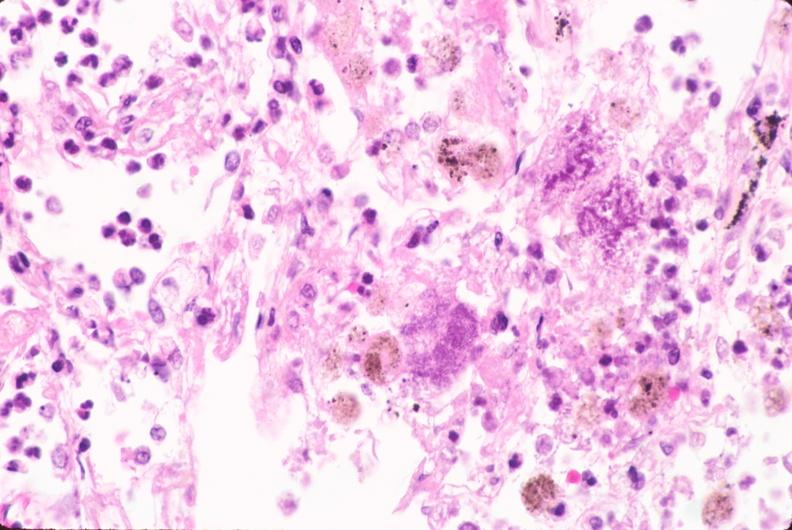s gangrene present?
Answer the question using a single word or phrase. No 